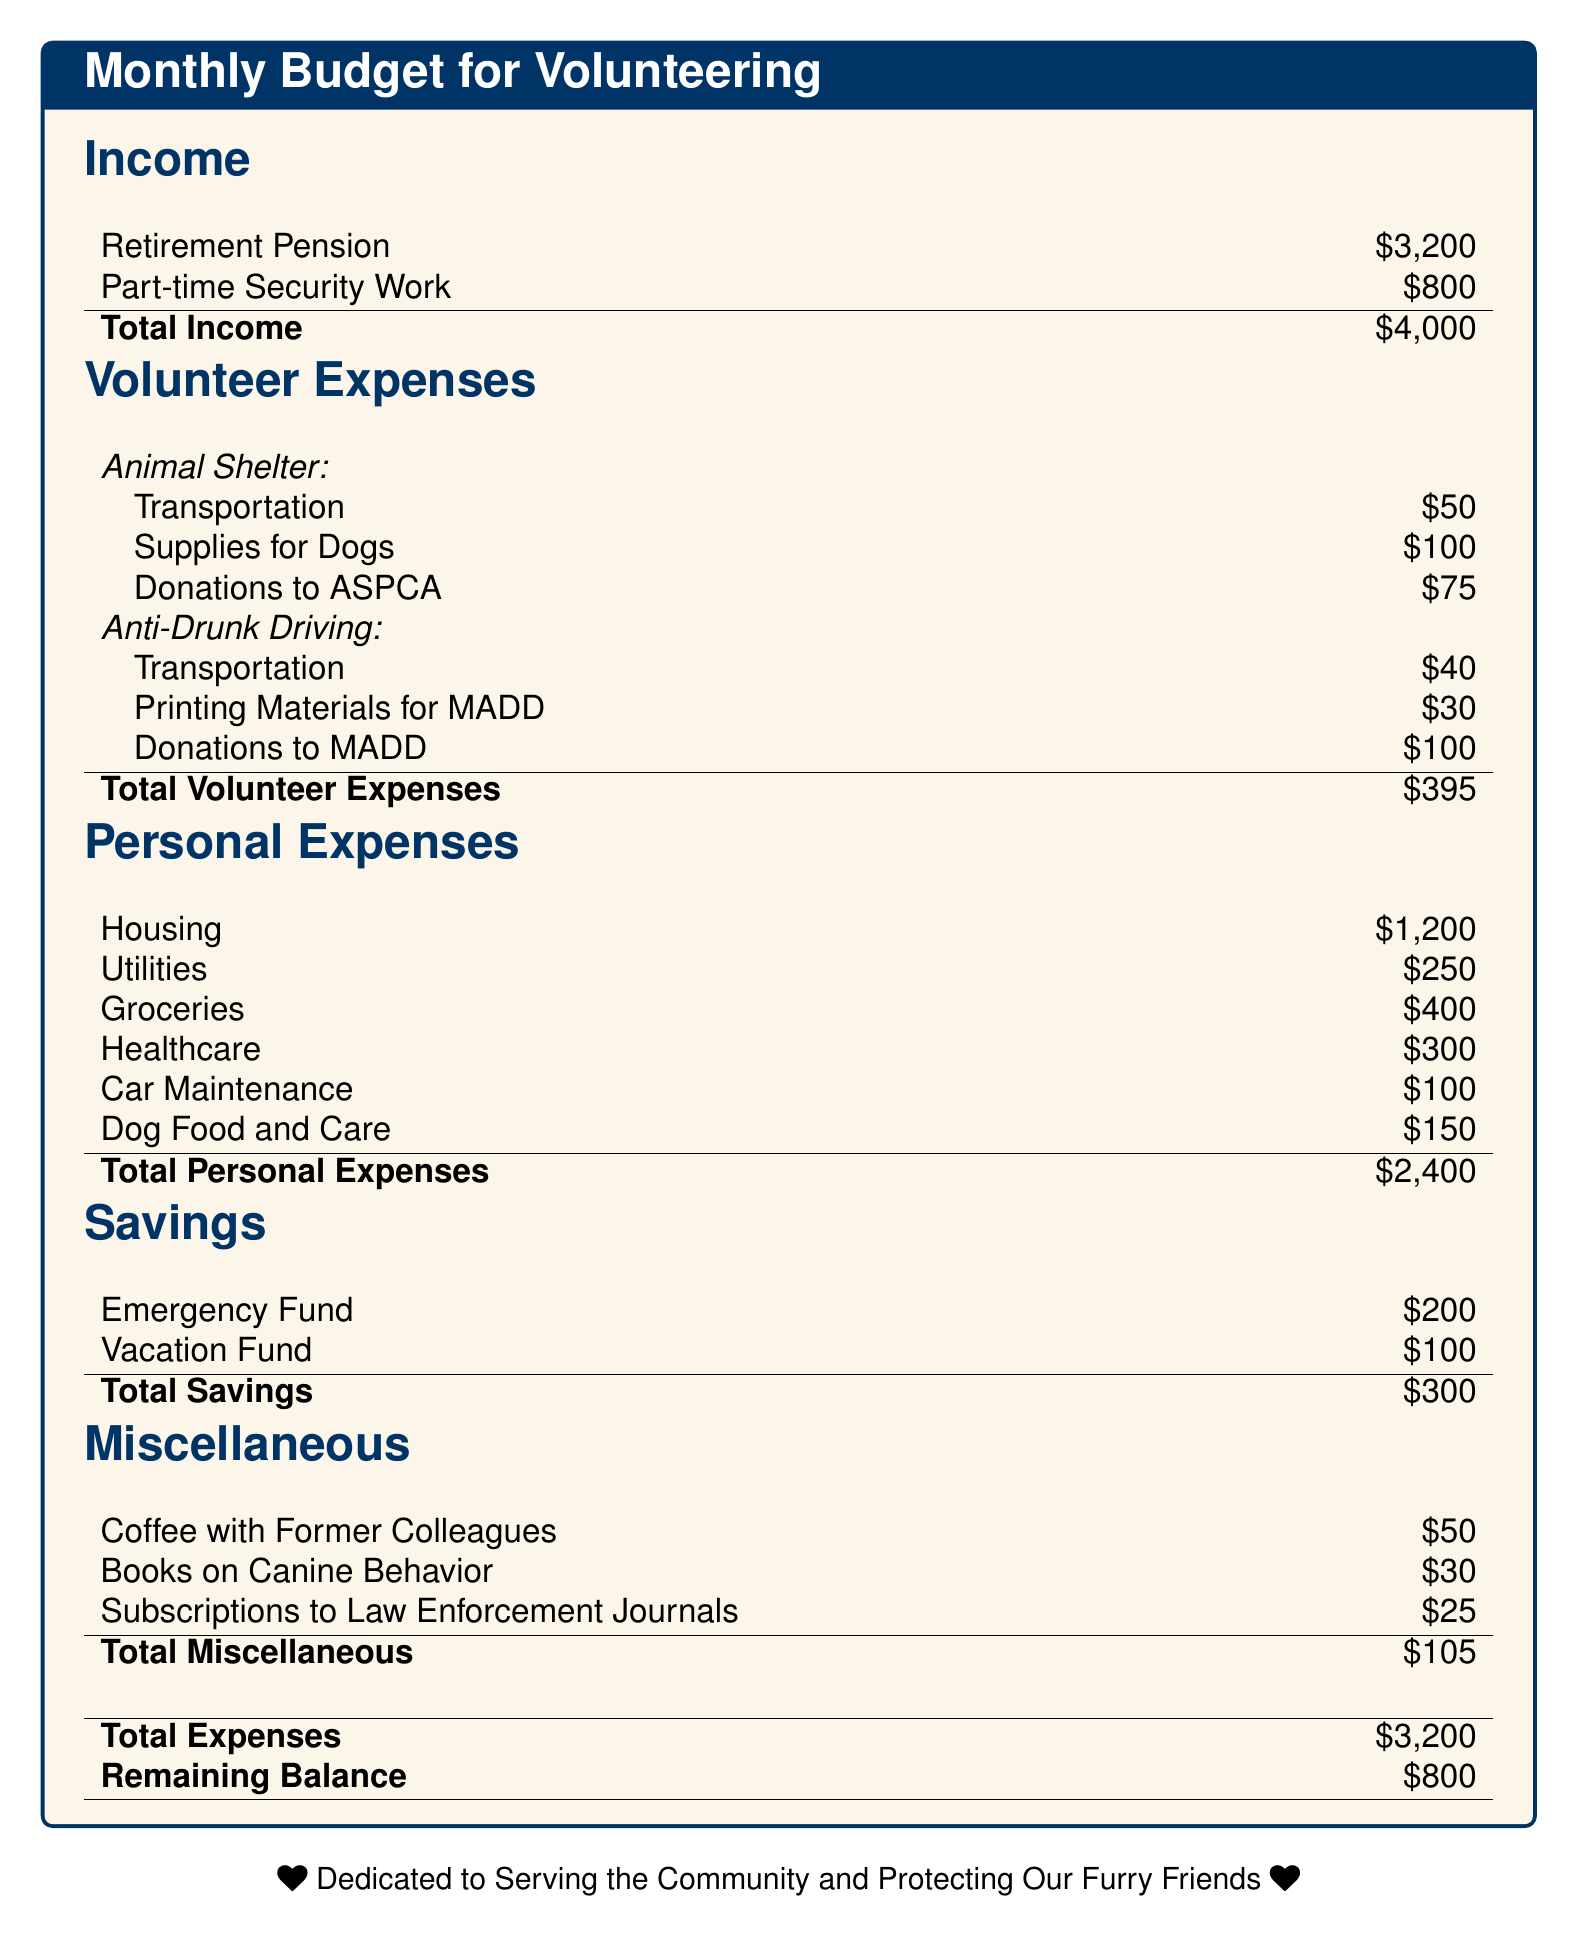What is the total income? The total income is the sum of all income sources in the document, which is $3200 + $800 = $4000.
Answer: $4000 What is the amount allocated for dog supplies? The document lists dog supplies under volunteer expenses for the animal shelter, which is $100.
Answer: $100 How much is the transportation cost for anti-drunk driving activities? The document states that transportation for anti-drunk driving costs $40.
Answer: $40 What is the total personal expenses? The document sums up all personal expenses, which amounts to $1200 + $250 + $400 + $300 + $100 + $150 = $2400.
Answer: $2400 What is the remaining balance after all expenses? The remaining balance is calculated by subtracting total expenses from total income, which is $4000 - $3200 = $800.
Answer: $800 What percentage of total income is dedicated to volunteer expenses? To find the percentage, divide total volunteer expenses by total income and multiply by 100, which is ($395 / $4000) * 100 = 9.875%.
Answer: Approximately 9.88% How much is spent on printing materials for MADD? The document specifies the printing materials for MADD are $30.
Answer: $30 What is the total amount saved in the savings category? The total savings are summed as $200 + $100 = $300.
Answer: $300 What miscellaneous expense is listed as the highest? The highest miscellaneous expense is coffee with former colleagues, costing $50.
Answer: $50 